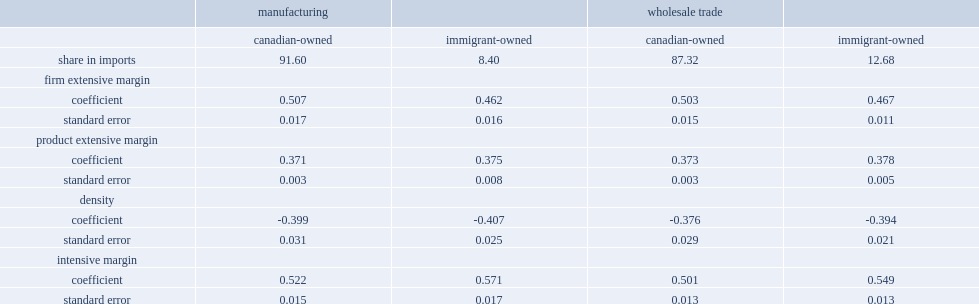What the percentage of the imports did immigrant-owned firms account for in the manufacuring sector? 8.4. Which firm margin's contribution is smaller when immigrant-owned and canadian-owned firms are compared? Firm extensive margin. Which firm margin's contribution is larger for imigrant-owned firms when immigrant-owned and canadian-owned firms are compared? Intensive margin. 